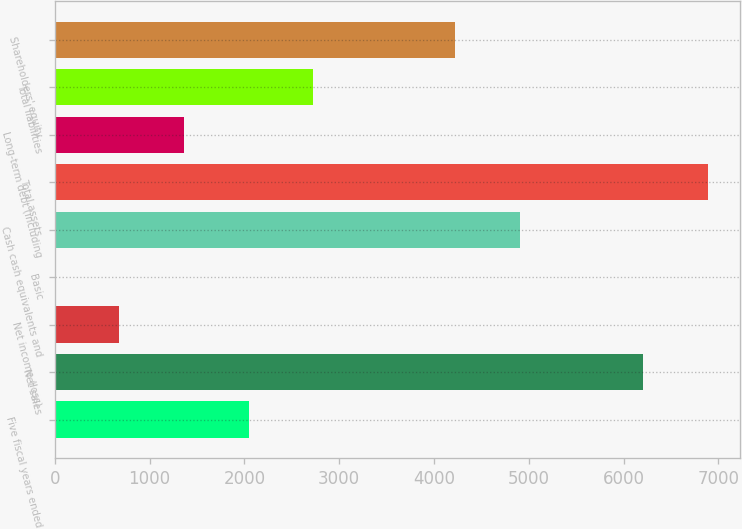<chart> <loc_0><loc_0><loc_500><loc_500><bar_chart><fcel>Five fiscal years ended<fcel>Net sales<fcel>Net income (loss)<fcel>Basic<fcel>Cash cash equivalents and<fcel>Total assets<fcel>Long-term debt (including<fcel>Total liabilities<fcel>Shareholders' equity<nl><fcel>2044.63<fcel>6207<fcel>681.67<fcel>0.19<fcel>4904.48<fcel>6888.48<fcel>1363.15<fcel>2726.11<fcel>4223<nl></chart> 